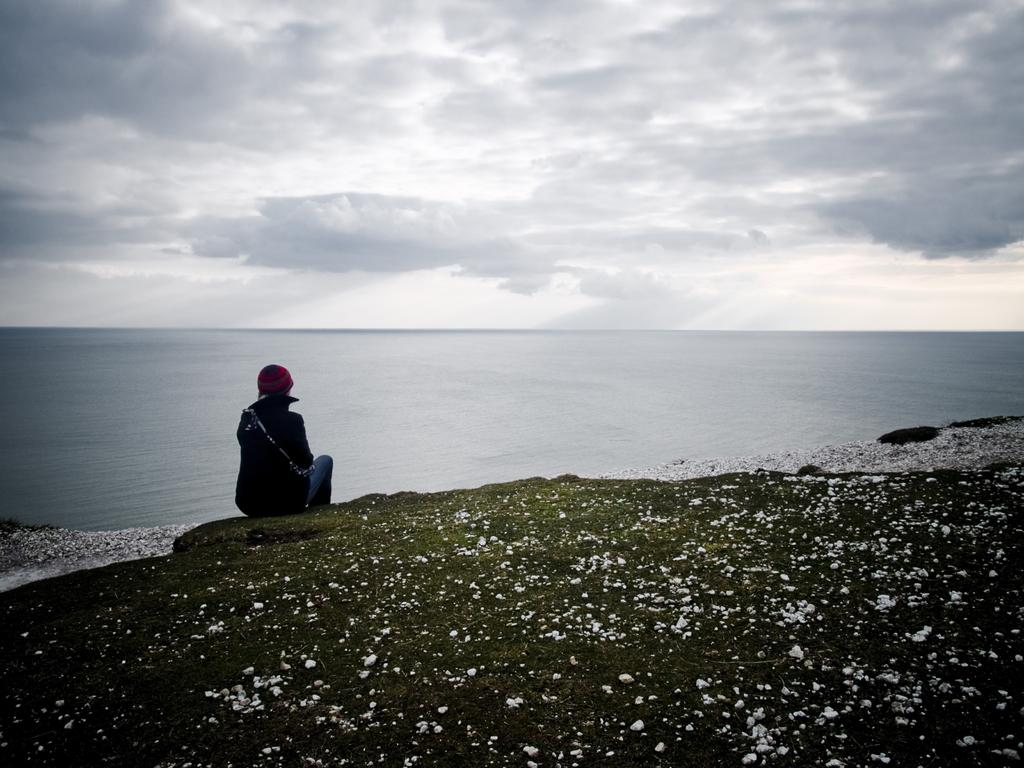What is the person in the image doing? There is a person sitting on the ground in the image. What can be seen in the background of the image? There is a water body in the background of the image. How would you describe the sky in the image? The sky is cloudy in the image. What type of surface is the person sitting on? There are stones on the ground in the image. What type of pump can be seen near the person's toes in the image? There is no pump present in the image, nor are there any toes visible. 